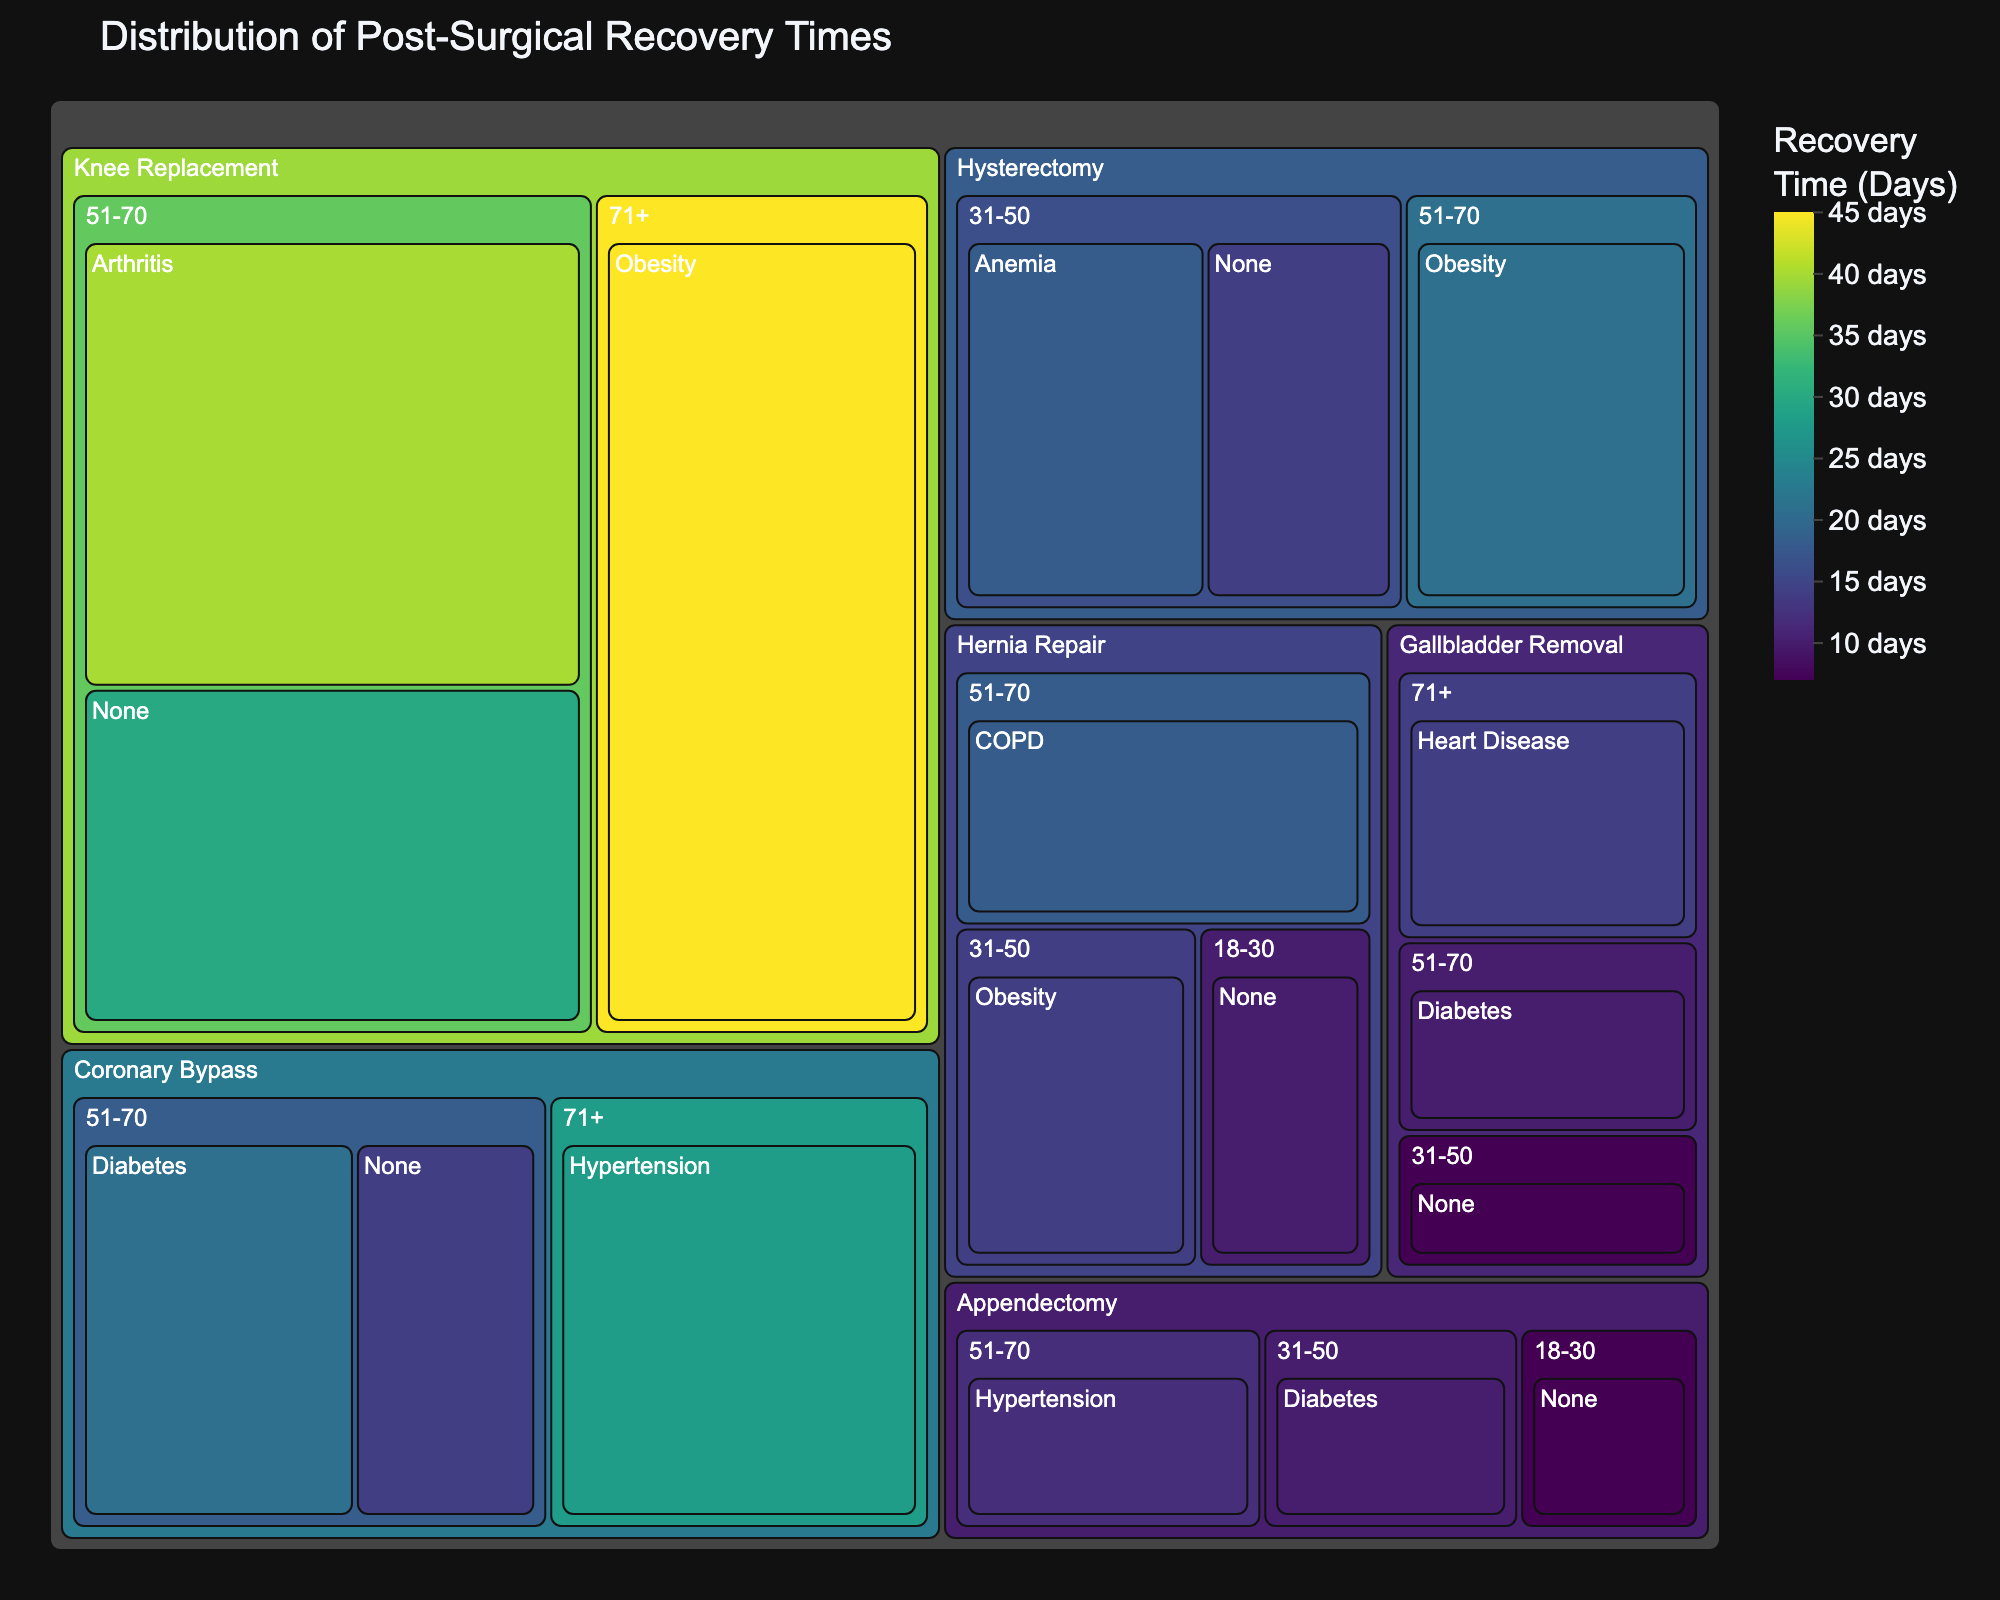What procedure has the longest recovery time? Look for the procedure segment in the treemap with the highest recovery time value.
Answer: Knee Replacement What is the recovery time for Coronary Bypass in patients aged 71+ with Hypertension? Find the 'Coronary Bypass' segment, then the '71+' age group, and check the value for 'Hypertension'.
Answer: 28 days Which age group has the shortest recovery time for Gallbladder Removal? Find the 'Gallbladder Removal' segment and compare the recovery times for each age group.
Answer: 31-50 How does the recovery time for Hysterectomy in patients aged 51-70 with Obesity compare to those aged 31-50 with None? Look at 'Hysterectomy' and compare recovery times for '51-70' with 'Obesity' and '31-50' with 'None'.
Answer: 21 days is greater than 14 days What is the average recovery time for Appendectomy across all age groups and comorbidities? Calculate the average by summing all recovery times for Appendectomy and dividing by the number of data points for Appendectomy: (7 + 10 + 12) / 3.
Answer: 9.67 days Is the recovery time for Hernia Repair in patients aged 51-70 with COPD higher than for those aged 18-30 with None? Compare recovery times for 'Hernia Repair' in '51-70' with 'COPD' and '18-30' with 'None'.
Answer: Yes What comorbidity is associated with the highest recovery time for Knee Replacement in patients aged 51-70? Look at the 'Knee Replacement' segment, then '51-70' age group, and compare the recovery times for each comorbidity.
Answer: Arthritis Which procedure has the least variation in recovery times across different age groups and comorbidities? Compare the range (max-min) of recovery times for each procedure segment.
Answer: Gallbladder Removal 